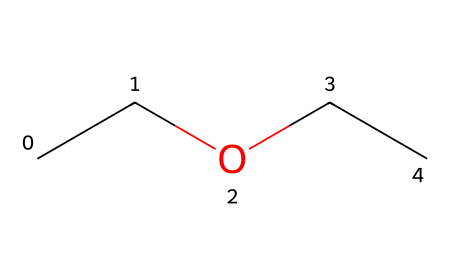What is the name of this compound? The SMILES representation "CCOCC" corresponds to diethyl ether, where "CC" indicates ethyl groups and "O" denotes the ether linkage.
Answer: diethyl ether How many carbon atoms are in diethyl ether? The structure contains four carbon atoms: two from each ethyl group indicated by "CC" on either side of the oxygen "O."
Answer: four How many oxygen atoms are present? The structure includes a single oxygen atom, represented by "O" within the SMILES notation.
Answer: one What type of functional group is present in this compound? Diethyl ether contains an ether functional group, characterized by the presence of an oxygen atom bonded to two carbon chains.
Answer: ether What is the overall molecular formula for diethyl ether? Analyzing the structure provides a total of 4 carbon atoms, 10 hydrogen atoms, and 1 oxygen atom, yielding the molecular formula C4H10O.
Answer: C4H10O How many total bonds are there in diethyl ether? Counting the bonds involves recognizing that there are 4 C-C bonds, 1 C-O bond, and each carbon is bonded to enough hydrogens to satisfy tetravalency, contributing additional C-H bonds, totaling 9 bonds.
Answer: nine What is the significance of diethyl ether in e-ink technology? Diethyl ether serves as a solvent or medium within e-ink systems, impacting the dispersion of particles and the technology's overall performance.
Answer: solvent 